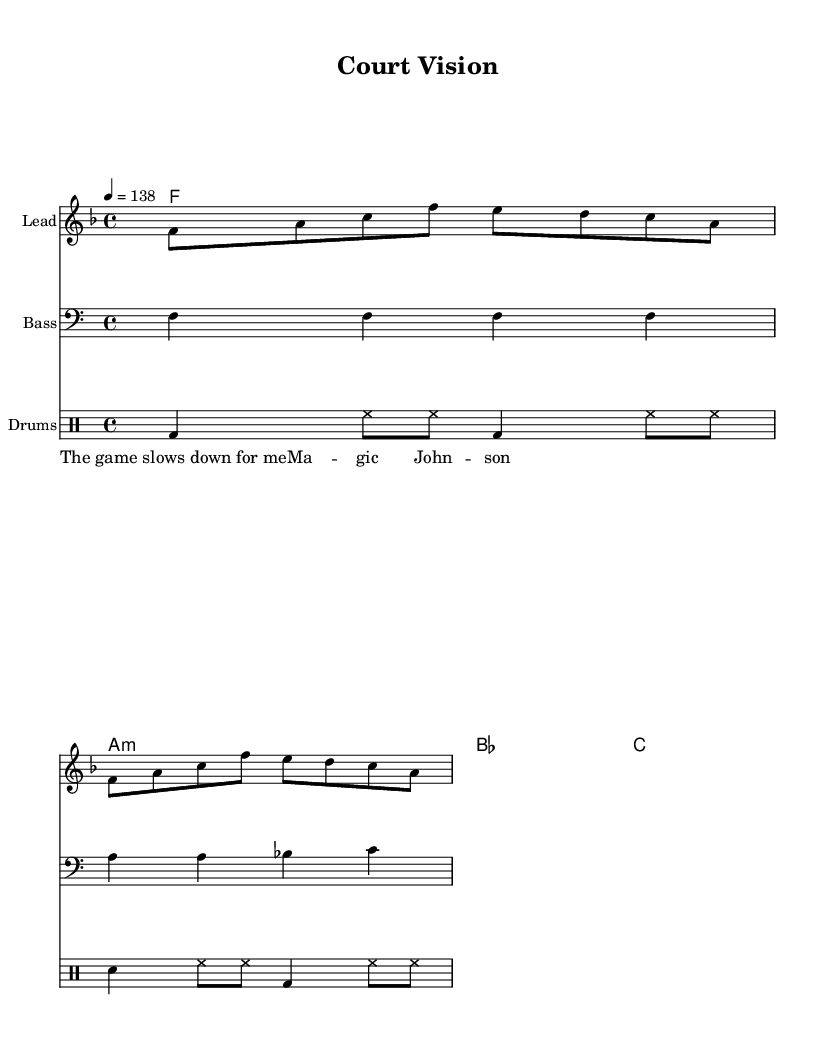What is the key signature of this music? The key signature is F major, which includes one flat (B flat). We determine this by looking at the key signature indicated at the beginning of the staff.
Answer: F major What is the time signature for this piece? The time signature is 4/4, as shown at the beginning of the score. This means there are four beats per measure and a quarter note receives one beat.
Answer: 4/4 What is the tempo marking? The tempo marking is 138 beats per minute, indicating the speed at which the piece should be played. This is clearly stated at the start of the score.
Answer: 138 How many measures are in the melody? There are 4 measures in the melody, which can be counted by looking at the notation in the melody staff. Each group of notes separated by vertical lines (bars) represents one measure.
Answer: 4 What is the chord used in the second measure of the harmony? The chord in the second measure is A minor, which is indicated in the chord staff. Chords are notated above the staff, and here it clearly shows A minor (a:m).
Answer: A minor What type of drum pattern is being used? The drum pattern includes bass drums (bd) and hi-hat (hh) as indicated in the drum staff. This style is characteristic of dance music to maintain a steady beat.
Answer: Bass and hi-hat Who is quoted in the lyrics of the song? The lyrics quote Magic Johnson, noted as “The game slows down for me,” which is indicated below the melody. This ties the lyrics to the inspirational context from the legendary point guard.
Answer: Magic Johnson 